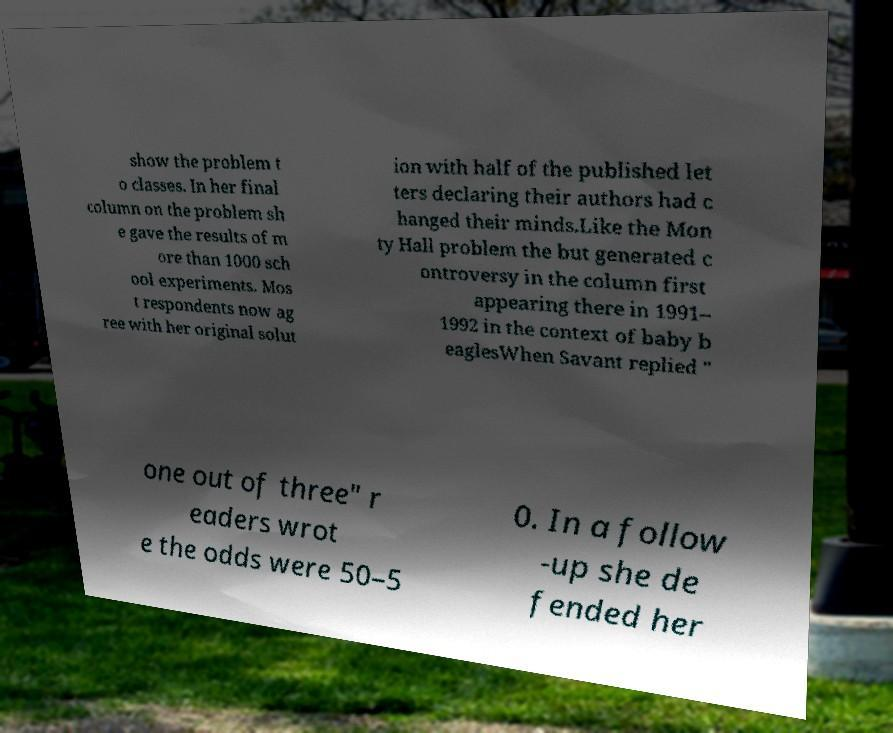Could you extract and type out the text from this image? show the problem t o classes. In her final column on the problem sh e gave the results of m ore than 1000 sch ool experiments. Mos t respondents now ag ree with her original solut ion with half of the published let ters declaring their authors had c hanged their minds.Like the Mon ty Hall problem the but generated c ontroversy in the column first appearing there in 1991– 1992 in the context of baby b eaglesWhen Savant replied " one out of three" r eaders wrot e the odds were 50–5 0. In a follow -up she de fended her 